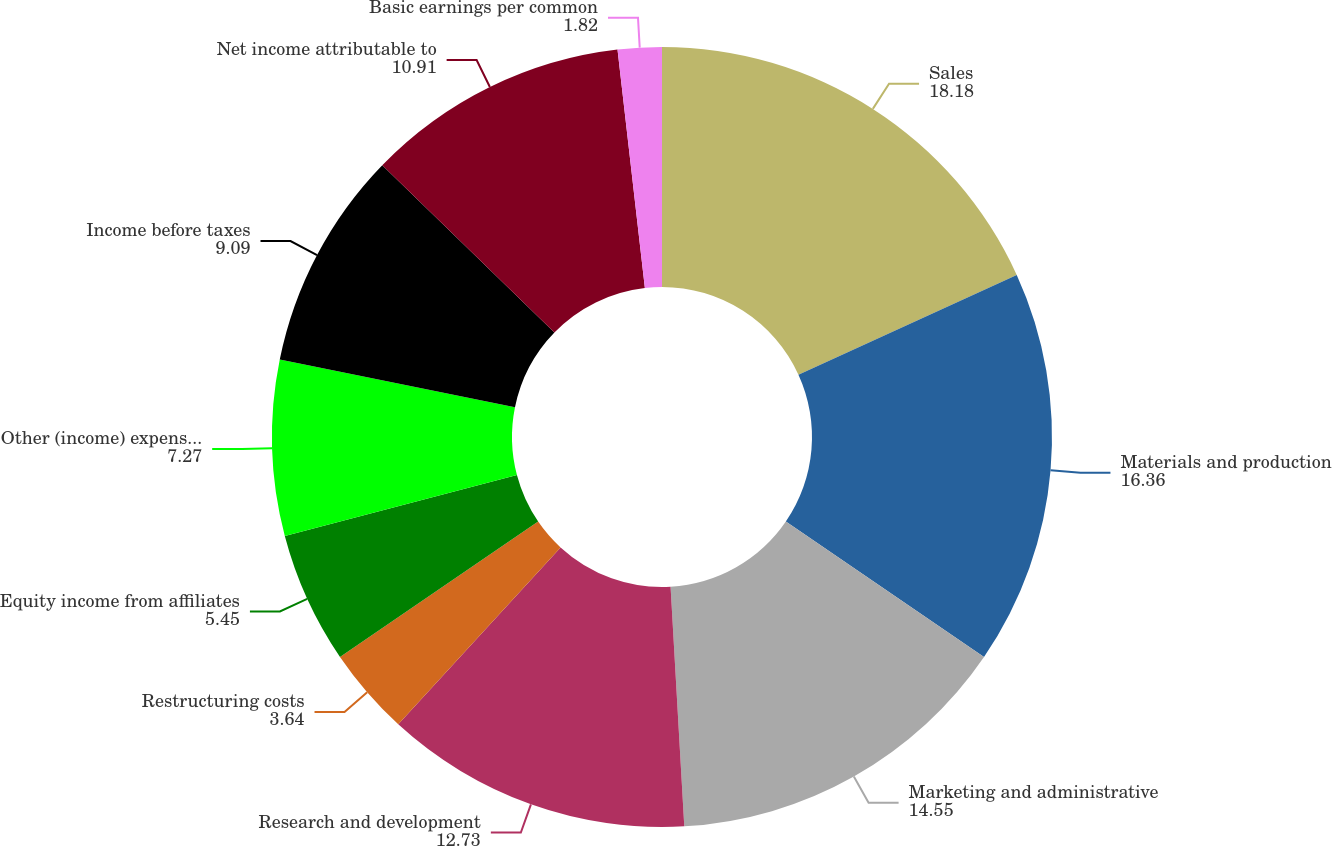<chart> <loc_0><loc_0><loc_500><loc_500><pie_chart><fcel>Sales<fcel>Materials and production<fcel>Marketing and administrative<fcel>Research and development<fcel>Restructuring costs<fcel>Equity income from affiliates<fcel>Other (income) expense net<fcel>Income before taxes<fcel>Net income attributable to<fcel>Basic earnings per common<nl><fcel>18.18%<fcel>16.36%<fcel>14.55%<fcel>12.73%<fcel>3.64%<fcel>5.45%<fcel>7.27%<fcel>9.09%<fcel>10.91%<fcel>1.82%<nl></chart> 